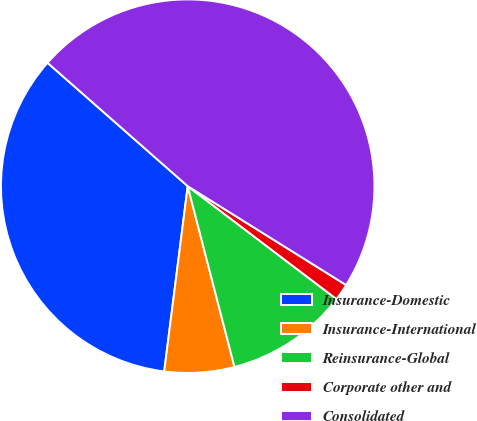Convert chart to OTSL. <chart><loc_0><loc_0><loc_500><loc_500><pie_chart><fcel>Insurance-Domestic<fcel>Insurance-International<fcel>Reinsurance-Global<fcel>Corporate other and<fcel>Consolidated<nl><fcel>34.48%<fcel>6.04%<fcel>10.64%<fcel>1.45%<fcel>47.4%<nl></chart> 